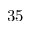<formula> <loc_0><loc_0><loc_500><loc_500>3 5</formula> 